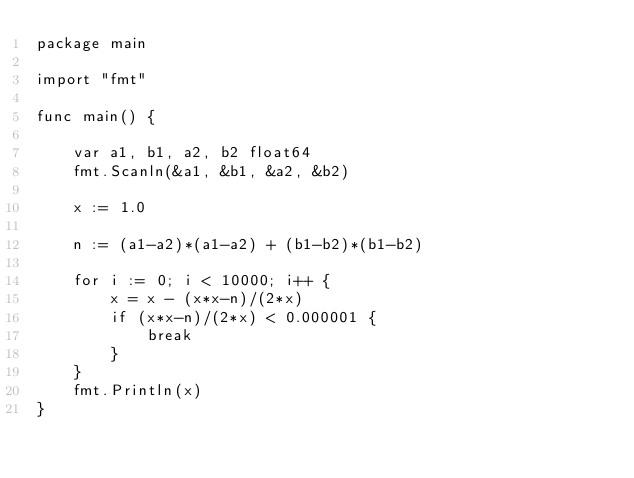Convert code to text. <code><loc_0><loc_0><loc_500><loc_500><_Go_>package main

import "fmt"

func main() {

	var a1, b1, a2, b2 float64
	fmt.Scanln(&a1, &b1, &a2, &b2)

	x := 1.0

	n := (a1-a2)*(a1-a2) + (b1-b2)*(b1-b2)

	for i := 0; i < 10000; i++ {
		x = x - (x*x-n)/(2*x)
		if (x*x-n)/(2*x) < 0.000001 {
			break
		}
	}
	fmt.Println(x)
}

</code> 